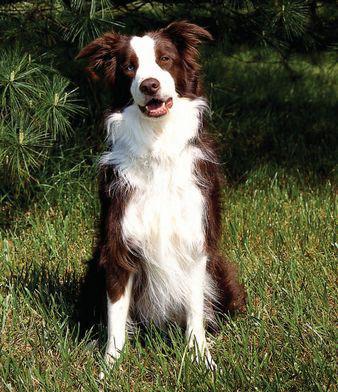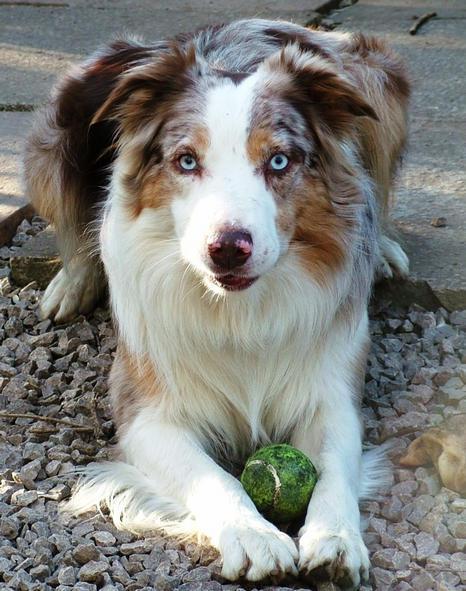The first image is the image on the left, the second image is the image on the right. Given the left and right images, does the statement "The dog in the image on the left is standing outside." hold true? Answer yes or no. No. 